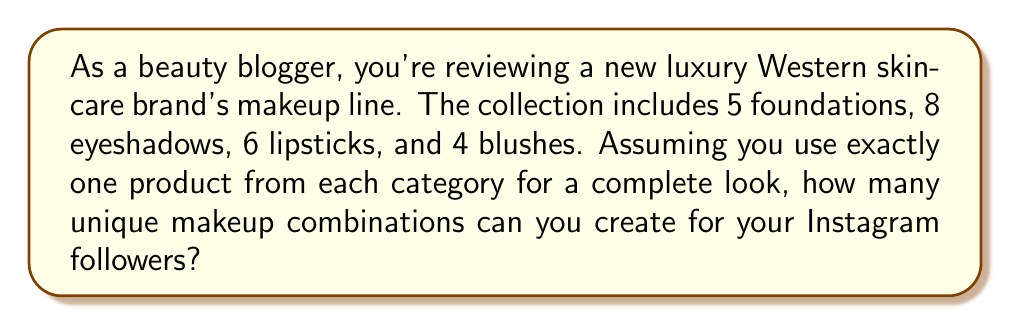Solve this math problem. To solve this problem, we'll use the multiplication principle of counting. This principle states that if we have a series of independent choices, the total number of possible outcomes is the product of the number of options for each choice.

In this case, we have four independent choices:

1. Foundation: 5 options
2. Eyeshadow: 8 options
3. Lipstick: 6 options
4. Blush: 4 options

For each complete makeup look, we choose one option from each category. Therefore, the total number of unique combinations is:

$$ 5 \times 8 \times 6 \times 4 = 960 $$

Let's break it down step by step:

1. Choose a foundation: 5 options
2. For each foundation choice, we have 8 eyeshadow options: $5 \times 8 = 40$
3. For each of these combinations, we have 6 lipstick options: $40 \times 6 = 240$
4. Finally, for each of these combinations, we have 4 blush options: $240 \times 4 = 960$

Thus, there are 960 unique makeup combinations possible with this Western skincare brand's makeup line.
Answer: 960 unique combinations 